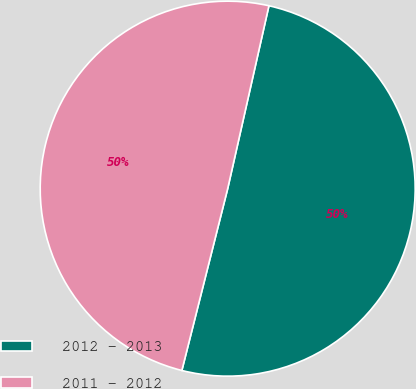<chart> <loc_0><loc_0><loc_500><loc_500><pie_chart><fcel>2012 - 2013<fcel>2011 - 2012<nl><fcel>50.4%<fcel>49.6%<nl></chart> 